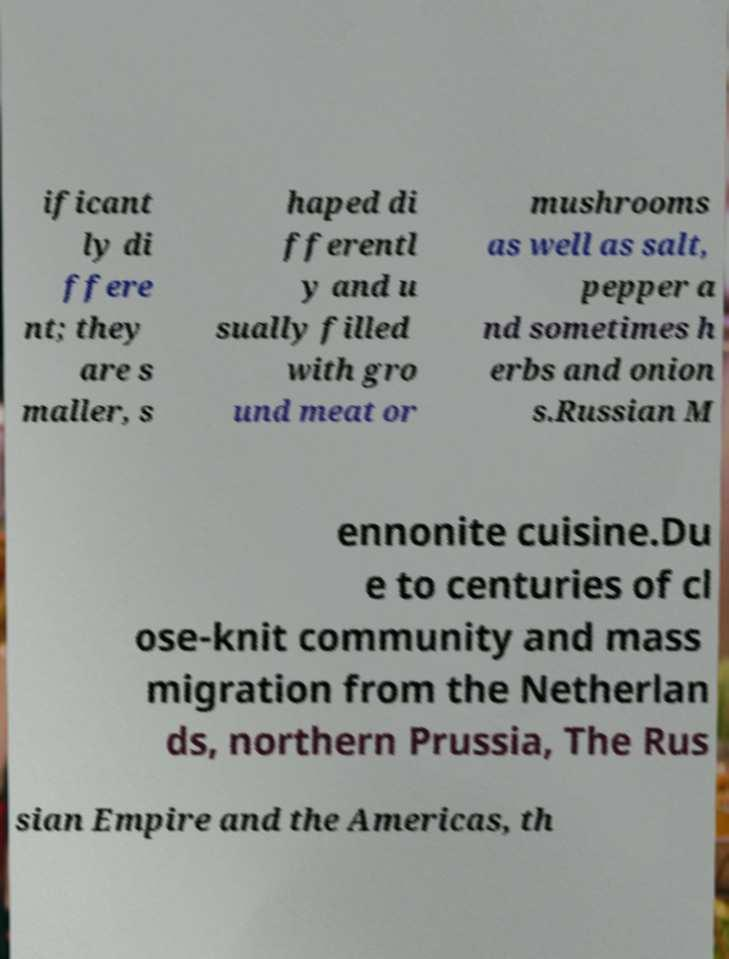Could you assist in decoding the text presented in this image and type it out clearly? ificant ly di ffere nt; they are s maller, s haped di fferentl y and u sually filled with gro und meat or mushrooms as well as salt, pepper a nd sometimes h erbs and onion s.Russian M ennonite cuisine.Du e to centuries of cl ose-knit community and mass migration from the Netherlan ds, northern Prussia, The Rus sian Empire and the Americas, th 